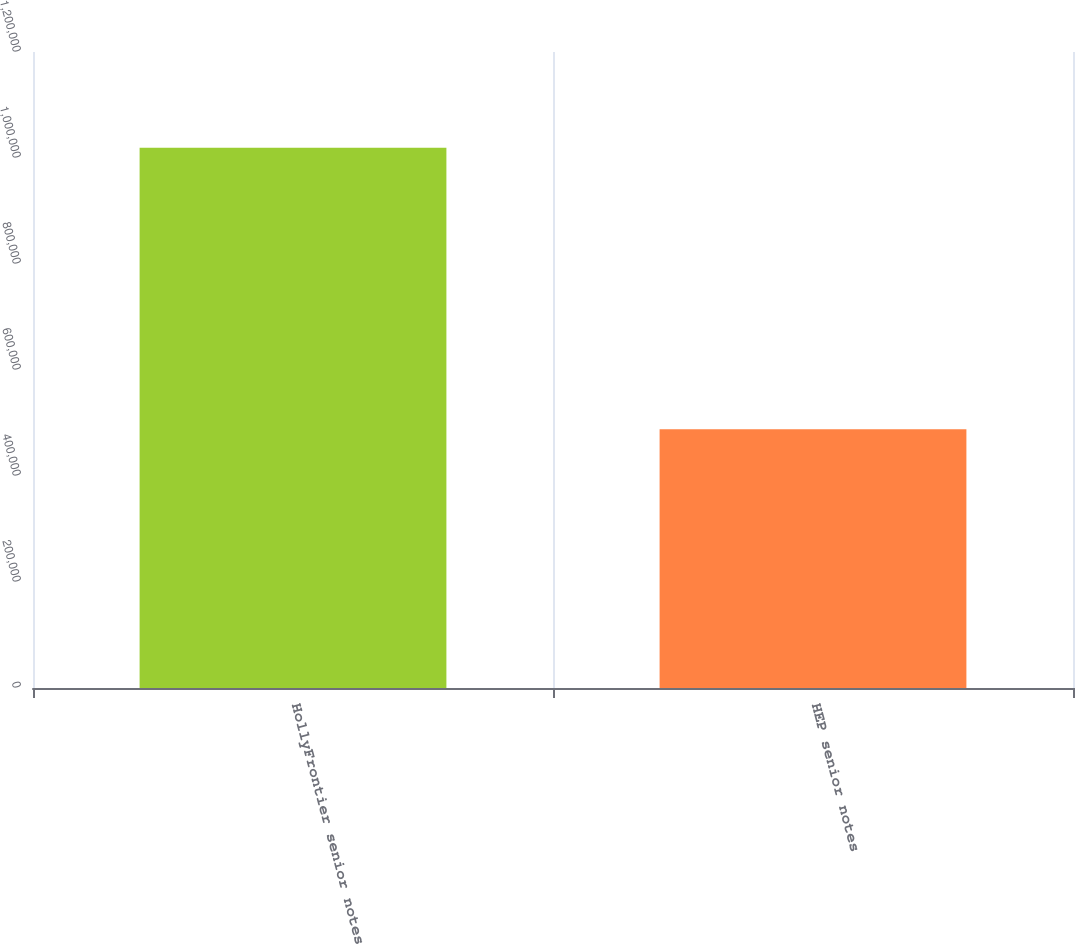<chart> <loc_0><loc_0><loc_500><loc_500><bar_chart><fcel>HollyFrontier senior notes<fcel>HEP senior notes<nl><fcel>1.01916e+06<fcel>488310<nl></chart> 